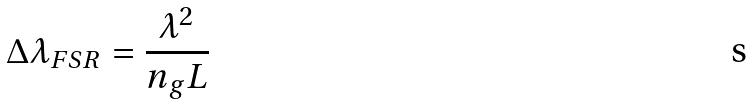<formula> <loc_0><loc_0><loc_500><loc_500>\Delta \lambda _ { F S R } = \frac { \lambda ^ { 2 } } { n _ { g } L }</formula> 